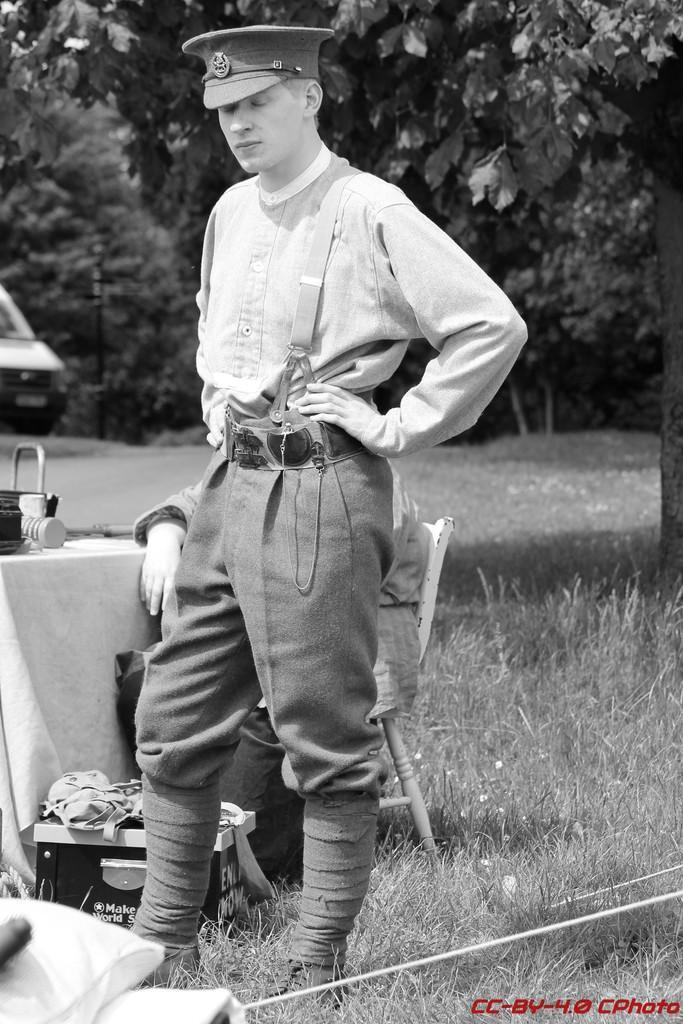Can you describe this image briefly? In this image we can see two people, among them one is standing and wearing a cap and the other one is sitting on the chair, there is a table covered with a cloth and there are some objects on it, we can see there are some trees, grass, vehicle, pole and other objects on the ground. 